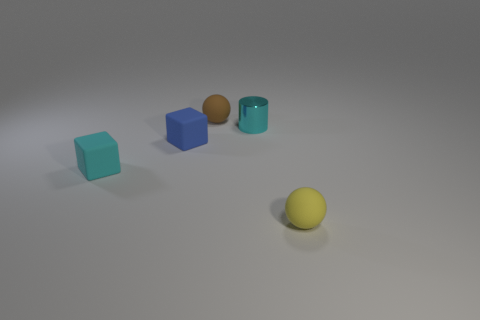Add 2 tiny yellow spheres. How many objects exist? 7 Subtract all spheres. How many objects are left? 3 Subtract all small objects. Subtract all green rubber cubes. How many objects are left? 0 Add 3 small rubber balls. How many small rubber balls are left? 5 Add 3 yellow matte things. How many yellow matte things exist? 4 Subtract 0 blue cylinders. How many objects are left? 5 